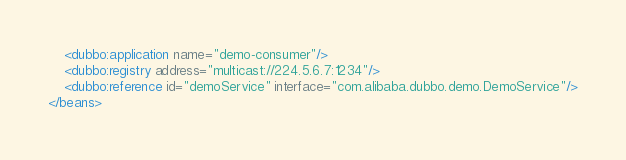Convert code to text. <code><loc_0><loc_0><loc_500><loc_500><_XML_>    <dubbo:application name="demo-consumer"/>
    <dubbo:registry address="multicast://224.5.6.7:1234"/>
    <dubbo:reference id="demoService" interface="com.alibaba.dubbo.demo.DemoService"/>
</beans>
</code> 